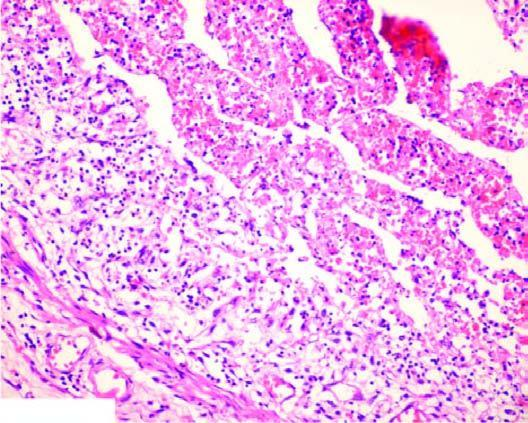s the lumen occluded by a thrombus containing microabscesses?
Answer the question using a single word or phrase. Yes 